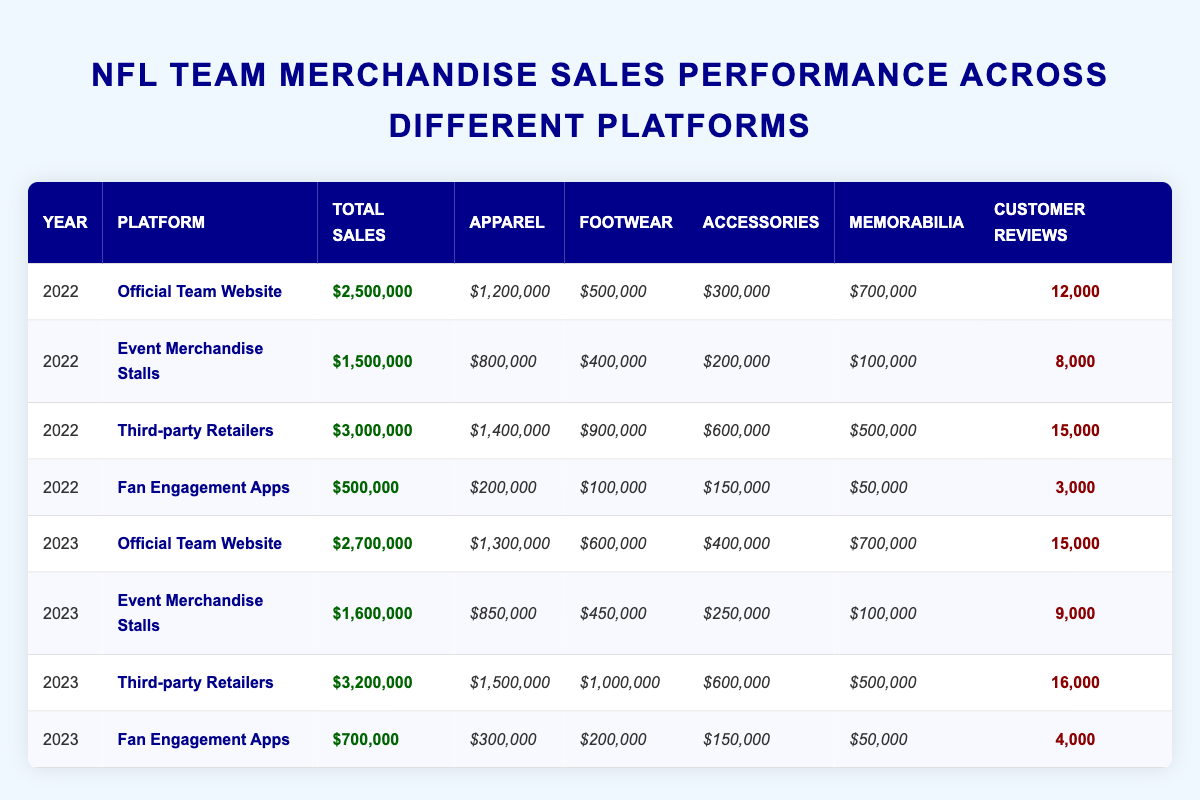What are the total sales for the Official Team Website in 2023? In the table, under the 2023 section for the Official Team Website, the total sales figure is bolded as $2,700,000.
Answer: $2,700,000 Which platform had the highest total sales in 2022? Reviewing the total sales values in 2022, the Third-party Retailers had the highest sales of $3,000,000.
Answer: Third-party Retailers How much did Fan Engagement Apps sell in 2023? The total sales figure for Fan Engagement Apps in 2023 is located in that row and amounts to $700,000.
Answer: $700,000 Is the total sales for Event Merchandise Stalls higher in 2023 than in 2022? In 2022, Event Merchandise Stalls had $1,500,000, while in 2023 it increased to $1,600,000. Thus, it is higher.
Answer: Yes What is the average total sales of all platforms in 2022? The total sales for all platforms in 2022 are $2,500,000 (Official Team Website) + $1,500,000 (Event Merchandise Stalls) + $3,000,000 (Third-party Retailers) + $500,000 (Fan Engagement Apps) = $7,500,000. There are four platforms, so the average is $7,500,000 / 4 = $1,875,000.
Answer: $1,875,000 Which category had the lowest sales in 2022 and what was the value? For 2022, looking at each category sales from all platforms, Memorabilia in the Fan Engagement Apps had the lowest sales at $50,000.
Answer: $50,000 Did the overall customer reviews increase from 2022 to 2023 across all platforms? Adding customer reviews for 2022 gives 12,000 + 8,000 + 15,000 + 3,000 = 38,000. For 2023, it totals 15,000 + 9,000 + 16,000 + 4,000 = 44,000. Therefore, it increased from 38,000 to 44,000.
Answer: Yes What platform had the largest growth in total sales from 2022 to 2023? The growth for each platform can be calculated: Official Team Website: $2,700,000 - $2,500,000 = $200,000; Event Merchandise Stalls: $1,600,000 - $1,500,000 = $100,000; Third-party Retailers: $3,200,000 - $3,000,000 = $200,000; Fan Engagement Apps: $700,000 - $500,000 = $200,000. Thus, the largest growth here is $200,000, shared among the Official Team Website, Third-party Retailers, and Fan Engagement Apps.
Answer: Official Team Website, Third-party Retailers, and Fan Engagement Apps What is the total sales difference between the highest and lowest performing platform in 2023? In 2023, the highest sales at Third-party Retailers is $3,200,000, and the lowest at Fan Engagement Apps is $700,000. The difference is $3,200,000 - $700,000 = $2,500,000.
Answer: $2,500,000 